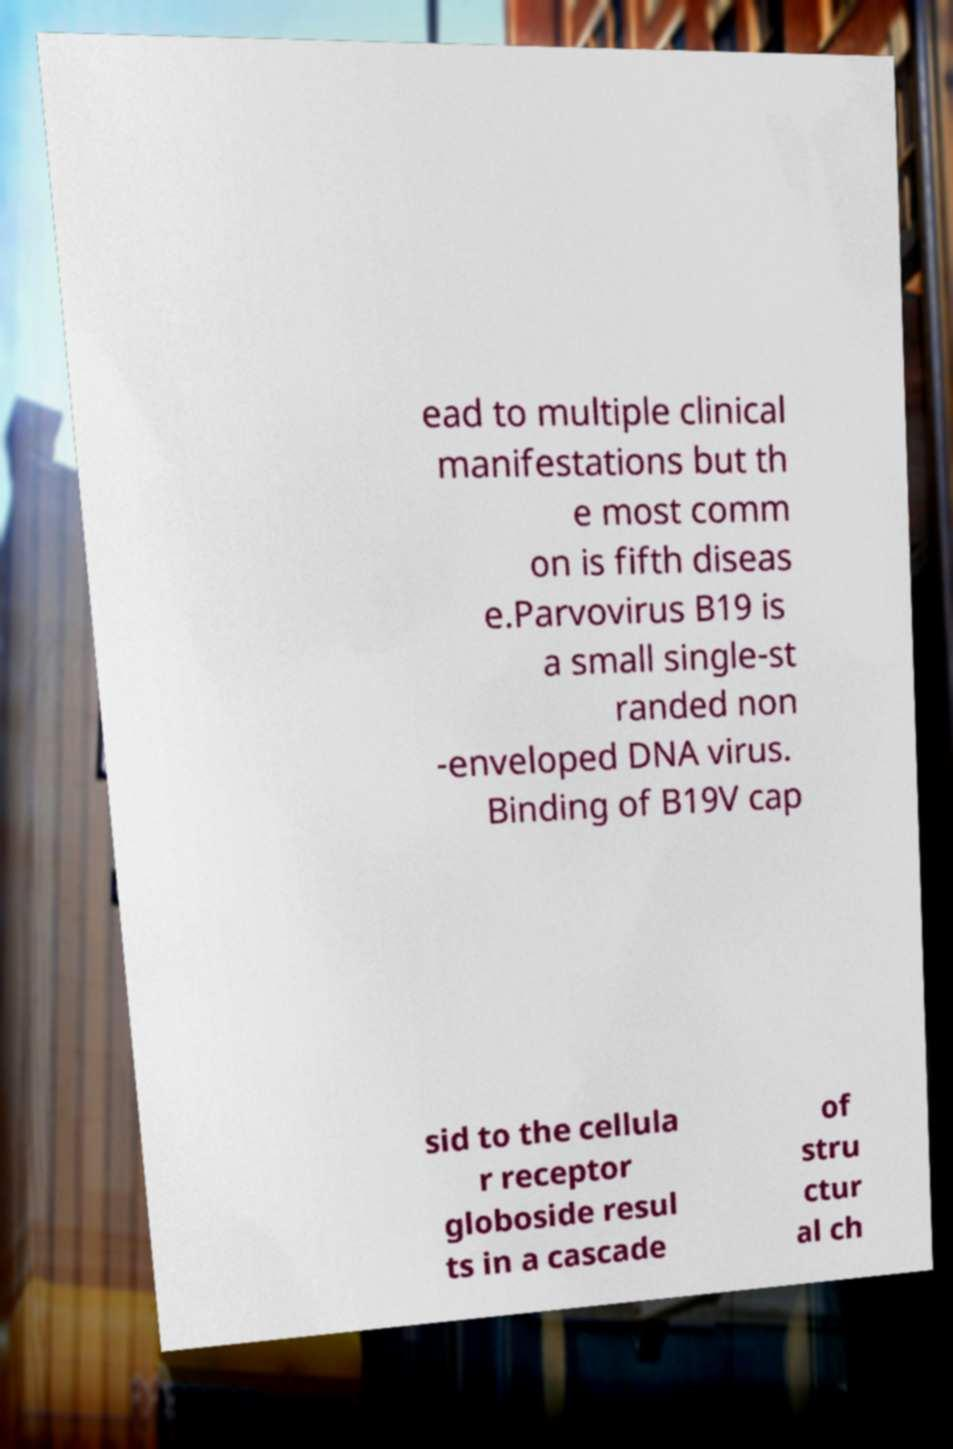I need the written content from this picture converted into text. Can you do that? ead to multiple clinical manifestations but th e most comm on is fifth diseas e.Parvovirus B19 is a small single-st randed non -enveloped DNA virus. Binding of B19V cap sid to the cellula r receptor globoside resul ts in a cascade of stru ctur al ch 